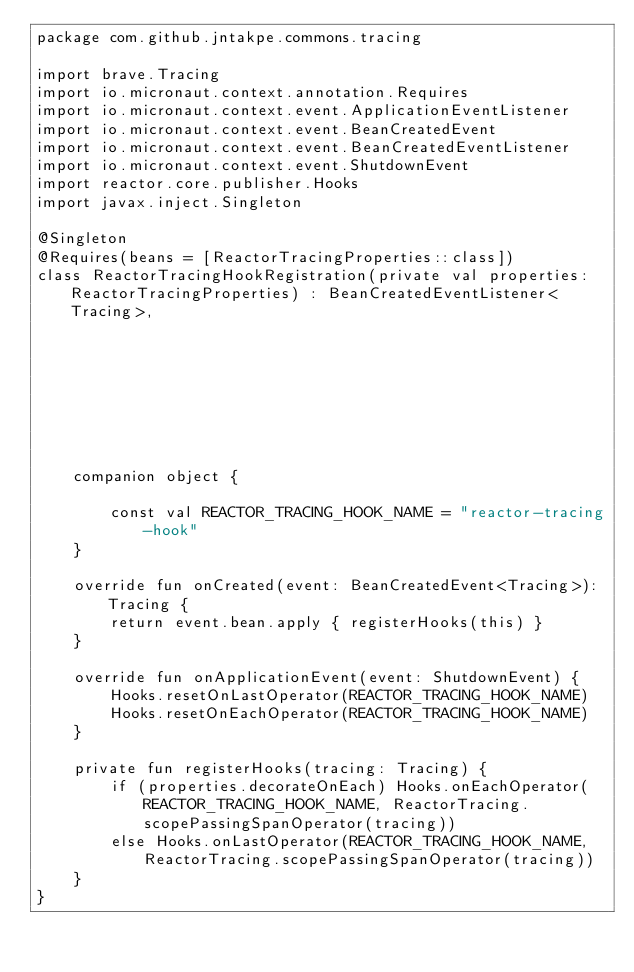<code> <loc_0><loc_0><loc_500><loc_500><_Kotlin_>package com.github.jntakpe.commons.tracing

import brave.Tracing
import io.micronaut.context.annotation.Requires
import io.micronaut.context.event.ApplicationEventListener
import io.micronaut.context.event.BeanCreatedEvent
import io.micronaut.context.event.BeanCreatedEventListener
import io.micronaut.context.event.ShutdownEvent
import reactor.core.publisher.Hooks
import javax.inject.Singleton

@Singleton
@Requires(beans = [ReactorTracingProperties::class])
class ReactorTracingHookRegistration(private val properties: ReactorTracingProperties) : BeanCreatedEventListener<Tracing>,
                                                                                         ApplicationEventListener<ShutdownEvent> {

    companion object {

        const val REACTOR_TRACING_HOOK_NAME = "reactor-tracing-hook"
    }

    override fun onCreated(event: BeanCreatedEvent<Tracing>): Tracing {
        return event.bean.apply { registerHooks(this) }
    }

    override fun onApplicationEvent(event: ShutdownEvent) {
        Hooks.resetOnLastOperator(REACTOR_TRACING_HOOK_NAME)
        Hooks.resetOnEachOperator(REACTOR_TRACING_HOOK_NAME)
    }

    private fun registerHooks(tracing: Tracing) {
        if (properties.decorateOnEach) Hooks.onEachOperator(REACTOR_TRACING_HOOK_NAME, ReactorTracing.scopePassingSpanOperator(tracing))
        else Hooks.onLastOperator(REACTOR_TRACING_HOOK_NAME, ReactorTracing.scopePassingSpanOperator(tracing))
    }
}
</code> 